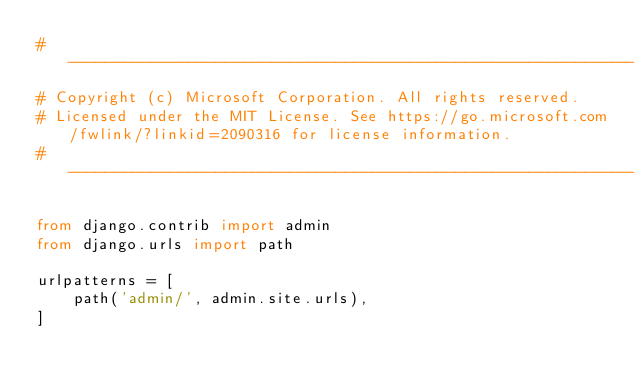Convert code to text. <code><loc_0><loc_0><loc_500><loc_500><_Python_>#-------------------------------------------------------------------------------------------------------------
# Copyright (c) Microsoft Corporation. All rights reserved.
# Licensed under the MIT License. See https://go.microsoft.com/fwlink/?linkid=2090316 for license information.
#-------------------------------------------------------------------------------------------------------------

from django.contrib import admin
from django.urls import path

urlpatterns = [
    path('admin/', admin.site.urls),
]
</code> 